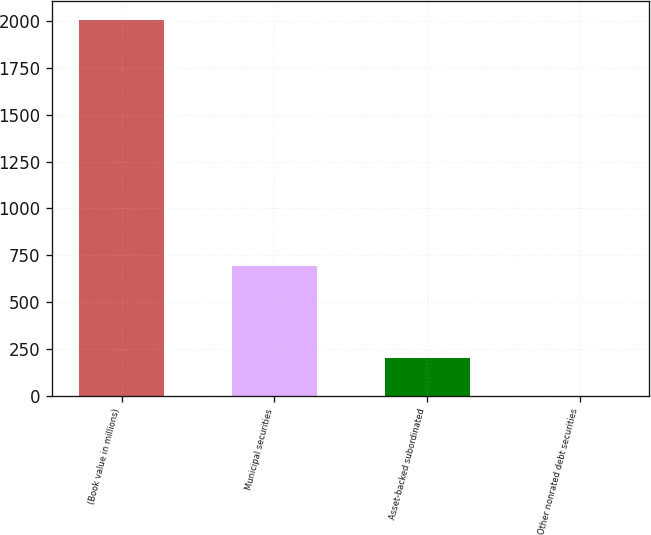<chart> <loc_0><loc_0><loc_500><loc_500><bar_chart><fcel>(Book value in millions)<fcel>Municipal securities<fcel>Asset-backed subordinated<fcel>Other nonrated debt securities<nl><fcel>2007<fcel>691<fcel>201.6<fcel>1<nl></chart> 